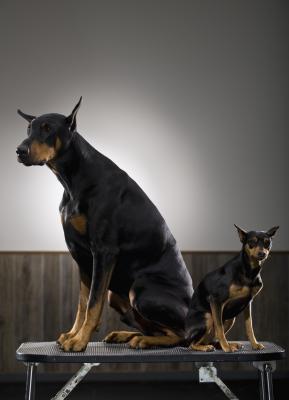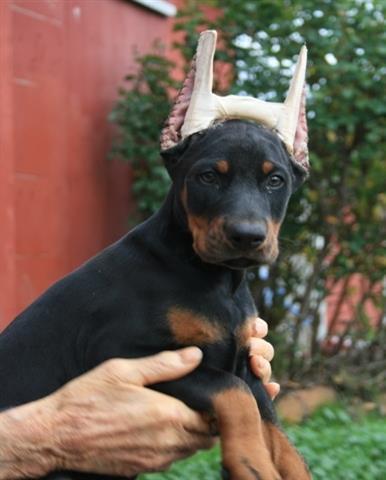The first image is the image on the left, the second image is the image on the right. Examine the images to the left and right. Is the description "The dog in the image on the left is situated in the grass." accurate? Answer yes or no. No. The first image is the image on the left, the second image is the image on the right. Given the left and right images, does the statement "An adult dog is with a puppy." hold true? Answer yes or no. Yes. 